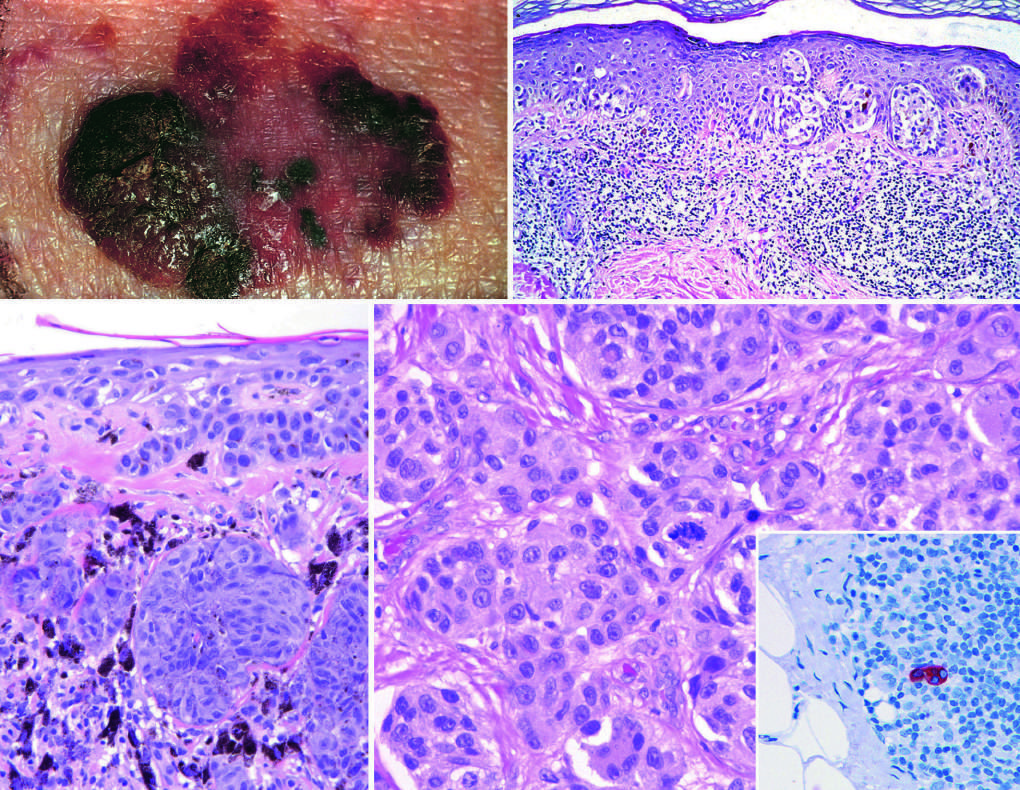s enchondroma in the center of the field?
Answer the question using a single word or phrase. No 